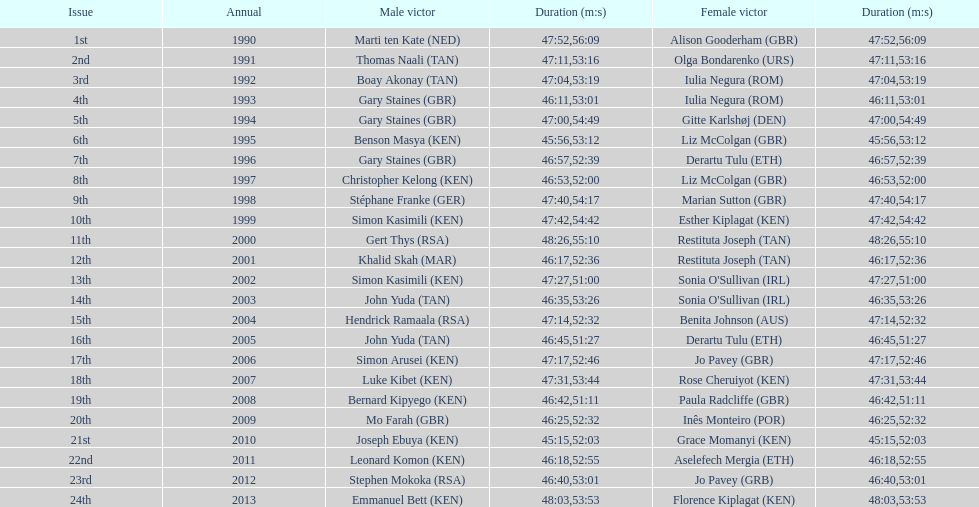Home many times did a single country win both the men's and women's bupa great south run? 4. Could you help me parse every detail presented in this table? {'header': ['Issue', 'Annual', 'Male victor', 'Duration (m:s)', 'Female victor', 'Duration (m:s)'], 'rows': [['1st', '1990', 'Marti ten Kate\xa0(NED)', '47:52', 'Alison Gooderham\xa0(GBR)', '56:09'], ['2nd', '1991', 'Thomas Naali\xa0(TAN)', '47:11', 'Olga Bondarenko\xa0(URS)', '53:16'], ['3rd', '1992', 'Boay Akonay\xa0(TAN)', '47:04', 'Iulia Negura\xa0(ROM)', '53:19'], ['4th', '1993', 'Gary Staines\xa0(GBR)', '46:11', 'Iulia Negura\xa0(ROM)', '53:01'], ['5th', '1994', 'Gary Staines\xa0(GBR)', '47:00', 'Gitte Karlshøj\xa0(DEN)', '54:49'], ['6th', '1995', 'Benson Masya\xa0(KEN)', '45:56', 'Liz McColgan\xa0(GBR)', '53:12'], ['7th', '1996', 'Gary Staines\xa0(GBR)', '46:57', 'Derartu Tulu\xa0(ETH)', '52:39'], ['8th', '1997', 'Christopher Kelong\xa0(KEN)', '46:53', 'Liz McColgan\xa0(GBR)', '52:00'], ['9th', '1998', 'Stéphane Franke\xa0(GER)', '47:40', 'Marian Sutton\xa0(GBR)', '54:17'], ['10th', '1999', 'Simon Kasimili\xa0(KEN)', '47:42', 'Esther Kiplagat\xa0(KEN)', '54:42'], ['11th', '2000', 'Gert Thys\xa0(RSA)', '48:26', 'Restituta Joseph\xa0(TAN)', '55:10'], ['12th', '2001', 'Khalid Skah\xa0(MAR)', '46:17', 'Restituta Joseph\xa0(TAN)', '52:36'], ['13th', '2002', 'Simon Kasimili\xa0(KEN)', '47:27', "Sonia O'Sullivan\xa0(IRL)", '51:00'], ['14th', '2003', 'John Yuda\xa0(TAN)', '46:35', "Sonia O'Sullivan\xa0(IRL)", '53:26'], ['15th', '2004', 'Hendrick Ramaala\xa0(RSA)', '47:14', 'Benita Johnson\xa0(AUS)', '52:32'], ['16th', '2005', 'John Yuda\xa0(TAN)', '46:45', 'Derartu Tulu\xa0(ETH)', '51:27'], ['17th', '2006', 'Simon Arusei\xa0(KEN)', '47:17', 'Jo Pavey\xa0(GBR)', '52:46'], ['18th', '2007', 'Luke Kibet\xa0(KEN)', '47:31', 'Rose Cheruiyot\xa0(KEN)', '53:44'], ['19th', '2008', 'Bernard Kipyego\xa0(KEN)', '46:42', 'Paula Radcliffe\xa0(GBR)', '51:11'], ['20th', '2009', 'Mo Farah\xa0(GBR)', '46:25', 'Inês Monteiro\xa0(POR)', '52:32'], ['21st', '2010', 'Joseph Ebuya\xa0(KEN)', '45:15', 'Grace Momanyi\xa0(KEN)', '52:03'], ['22nd', '2011', 'Leonard Komon\xa0(KEN)', '46:18', 'Aselefech Mergia\xa0(ETH)', '52:55'], ['23rd', '2012', 'Stephen Mokoka\xa0(RSA)', '46:40', 'Jo Pavey\xa0(GRB)', '53:01'], ['24th', '2013', 'Emmanuel Bett\xa0(KEN)', '48:03', 'Florence Kiplagat\xa0(KEN)', '53:53']]} 